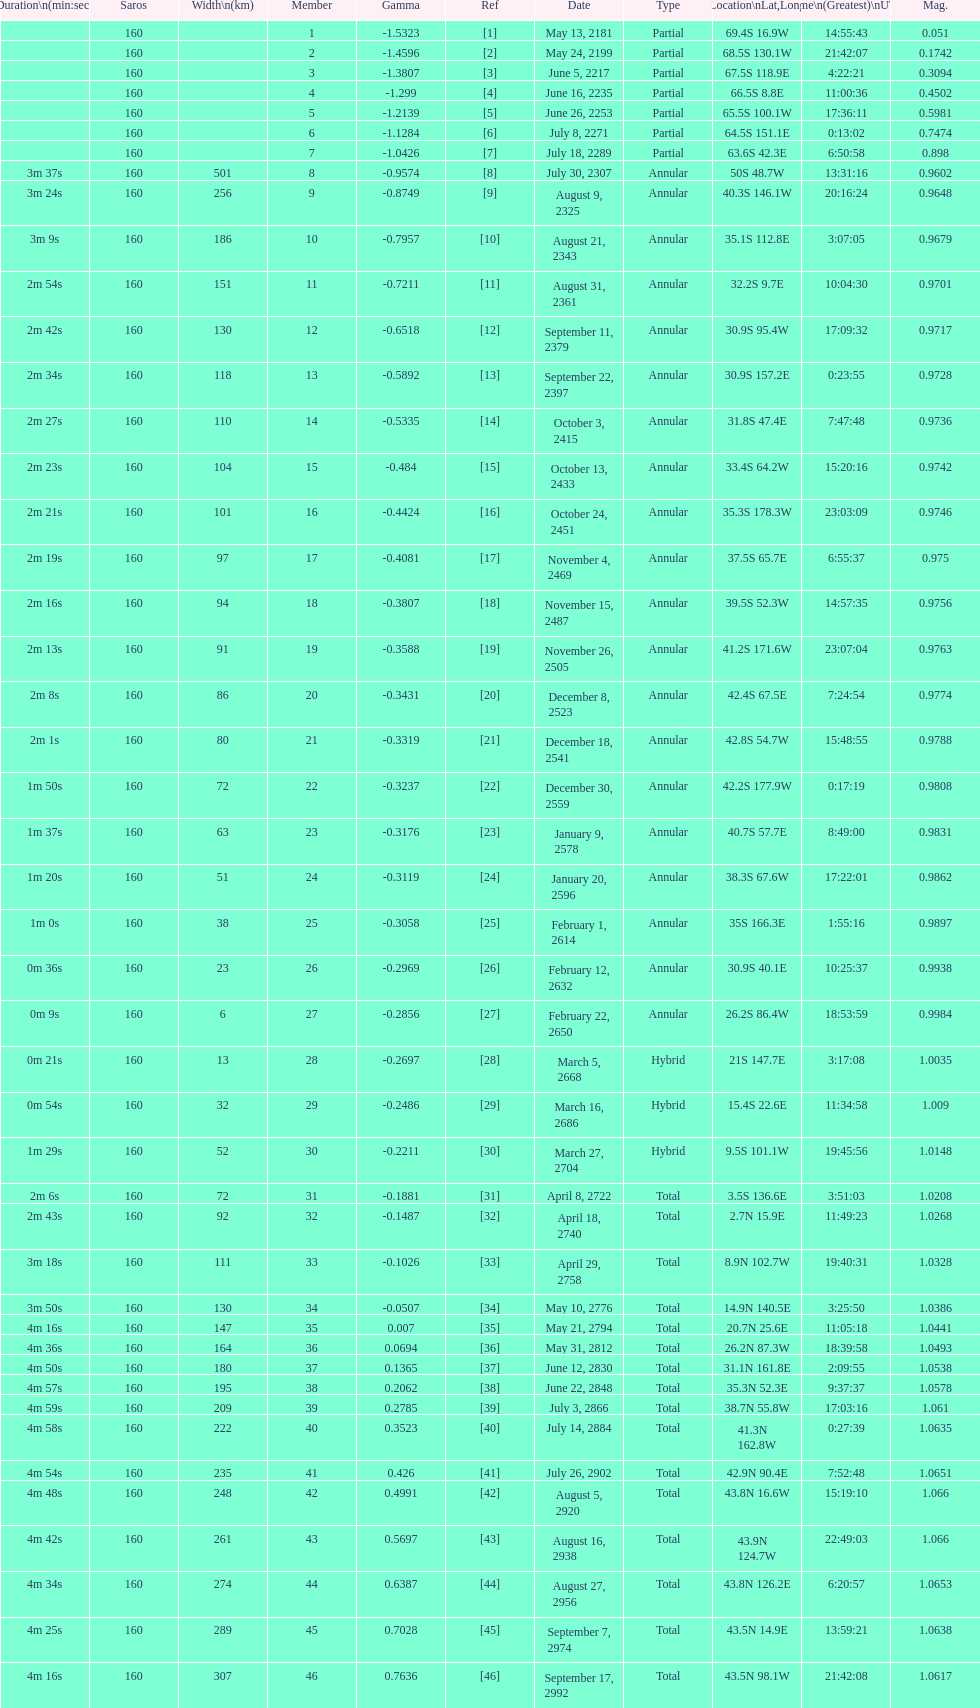How many solar saros events lasted longer than 4 minutes? 12. 